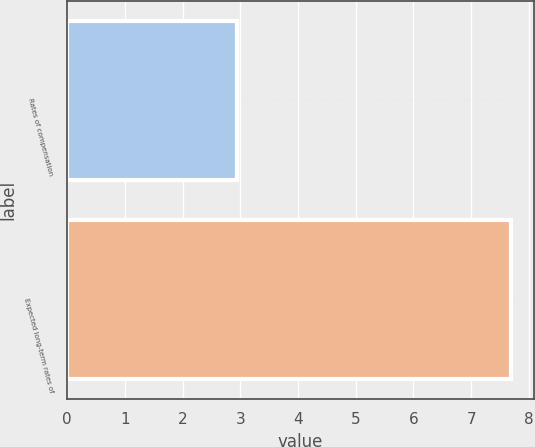<chart> <loc_0><loc_0><loc_500><loc_500><bar_chart><fcel>Rates of compensation<fcel>Expected long-term rates of<nl><fcel>2.95<fcel>7.7<nl></chart> 